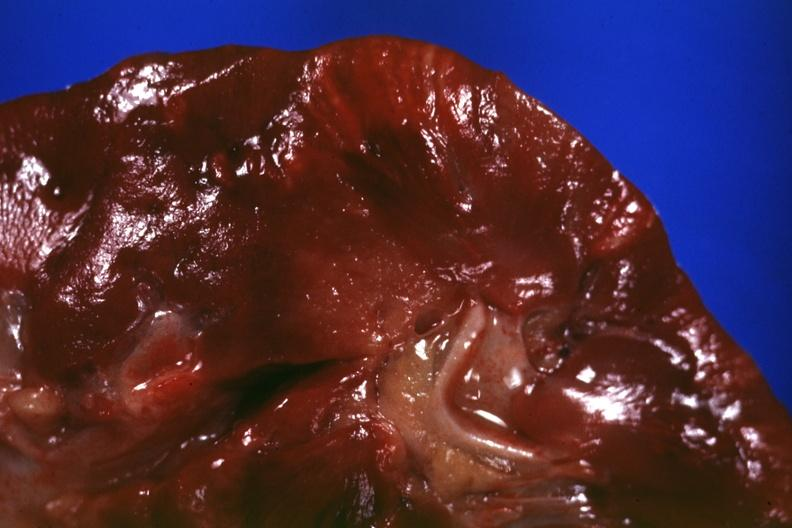s kidney present?
Answer the question using a single word or phrase. Yes 